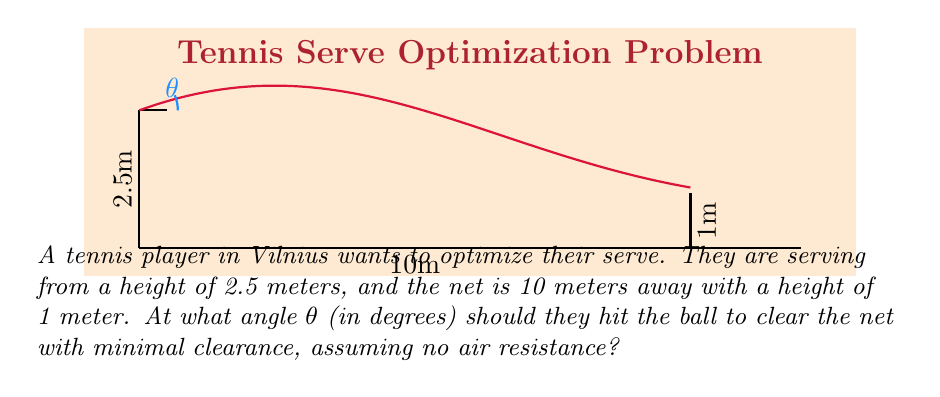What is the answer to this math problem? Let's approach this step-by-step using trigonometry:

1) We can model the ball's trajectory as a parabola. The optimal angle will be the one that allows the ball to just clear the net.

2) Let's use the equation of a projectile motion:
   $$y = \tan(\theta)x - \frac{g}{2v_0^2\cos^2(\theta)}x^2 + h$$
   where $y$ is the height, $x$ is the horizontal distance, $\theta$ is the launch angle, $g$ is the acceleration due to gravity (9.8 m/s²), $v_0$ is the initial velocity, and $h$ is the initial height.

3) We know that when $x = 10$ (at the net), $y$ should be slightly above 1. Let's say $y = 1.01$ to ensure clearance. Also, $h = 2.5$.

4) Substituting these values:
   $$1.01 = 10\tan(\theta) - \frac{4.9 \cdot 100}{v_0^2\cos^2(\theta)} + 2.5$$

5) We don't know $v_0$, but we can eliminate it by using the fact that the ball should reach its maximum height at $x = 5$ (halfway to the net). The derivative of $y$ with respect to $x$ should be zero at this point:
   $$\frac{dy}{dx} = \tan(\theta) - \frac{gx}{v_0^2\cos^2(\theta)} = 0$$
   when $x = 5$

6) From this, we can derive:
   $$v_0^2 = \frac{5g}{\sin(\theta)\cos(\theta)} = \frac{10g}{\sin(2\theta)}$$

7) Substituting this back into our original equation:
   $$1.01 = 10\tan(\theta) - \frac{490\sin(2\theta)}{100} + 2.5$$

8) Simplifying:
   $$-1.49 = 10\tan(\theta) - 4.9\sin(2\theta)$$

9) This equation can be solved numerically. Using a calculator or computer, we find that $\theta \approx 11.5°$.
Answer: $11.5°$ 